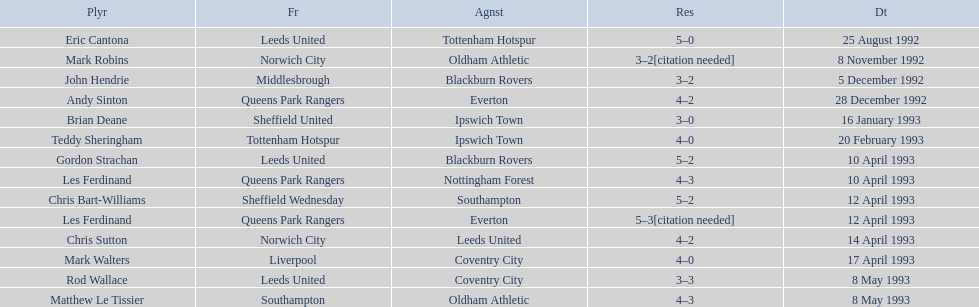Who are the players in 1992-93 fa premier league? Eric Cantona, Mark Robins, John Hendrie, Andy Sinton, Brian Deane, Teddy Sheringham, Gordon Strachan, Les Ferdinand, Chris Bart-Williams, Les Ferdinand, Chris Sutton, Mark Walters, Rod Wallace, Matthew Le Tissier. Parse the full table. {'header': ['Plyr', 'Fr', 'Agnst', 'Res', 'Dt'], 'rows': [['Eric Cantona', 'Leeds United', 'Tottenham Hotspur', '5–0', '25 August 1992'], ['Mark Robins', 'Norwich City', 'Oldham Athletic', '3–2[citation needed]', '8 November 1992'], ['John Hendrie', 'Middlesbrough', 'Blackburn Rovers', '3–2', '5 December 1992'], ['Andy Sinton', 'Queens Park Rangers', 'Everton', '4–2', '28 December 1992'], ['Brian Deane', 'Sheffield United', 'Ipswich Town', '3–0', '16 January 1993'], ['Teddy Sheringham', 'Tottenham Hotspur', 'Ipswich Town', '4–0', '20 February 1993'], ['Gordon Strachan', 'Leeds United', 'Blackburn Rovers', '5–2', '10 April 1993'], ['Les Ferdinand', 'Queens Park Rangers', 'Nottingham Forest', '4–3', '10 April 1993'], ['Chris Bart-Williams', 'Sheffield Wednesday', 'Southampton', '5–2', '12 April 1993'], ['Les Ferdinand', 'Queens Park Rangers', 'Everton', '5–3[citation needed]', '12 April 1993'], ['Chris Sutton', 'Norwich City', 'Leeds United', '4–2', '14 April 1993'], ['Mark Walters', 'Liverpool', 'Coventry City', '4–0', '17 April 1993'], ['Rod Wallace', 'Leeds United', 'Coventry City', '3–3', '8 May 1993'], ['Matthew Le Tissier', 'Southampton', 'Oldham Athletic', '4–3', '8 May 1993']]} What is mark robins' result? 3–2[citation needed]. Which player has the same result? John Hendrie. 